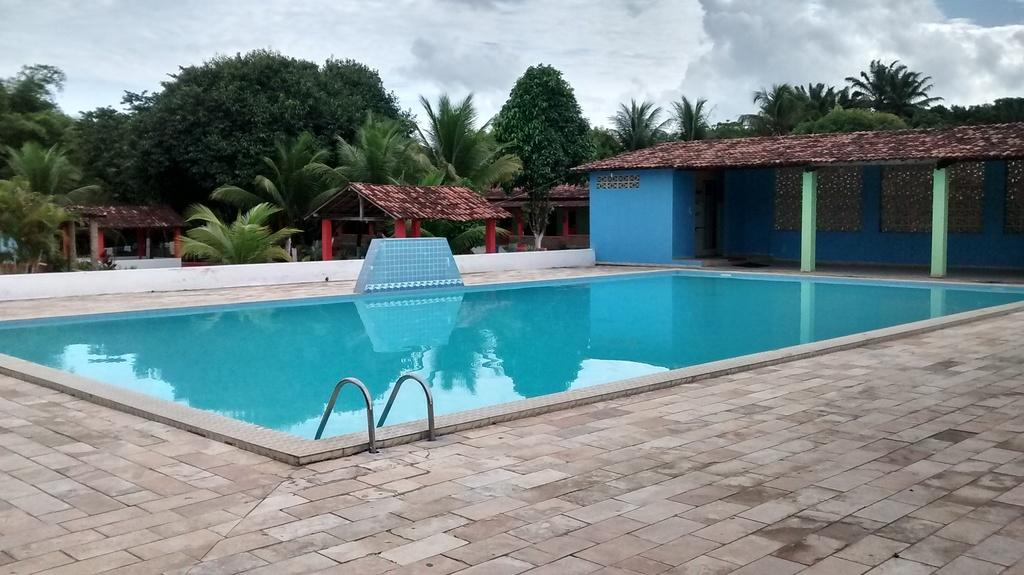What is the main feature of the image? There is a swimming pool in the image. What other structures can be seen in the image? There are huts in the image. What type of natural elements are present in the image? There are trees in the image. What can be seen in the background of the image? The sky is visible in the background of the image. What type of pot is being used to create a zephyr in the image? There is no pot or zephyr present in the image. What type of magic is being performed in the image? There is no magic or magical elements present in the image. 